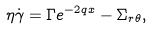<formula> <loc_0><loc_0><loc_500><loc_500>\eta \dot { \gamma } = \Gamma e ^ { - 2 q x } - \Sigma _ { r \theta } ,</formula> 